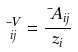Convert formula to latex. <formula><loc_0><loc_0><loc_500><loc_500>\mu _ { i j } ^ { V } = \frac { \mu A _ { i j } } { z _ { i } }</formula> 